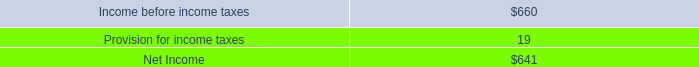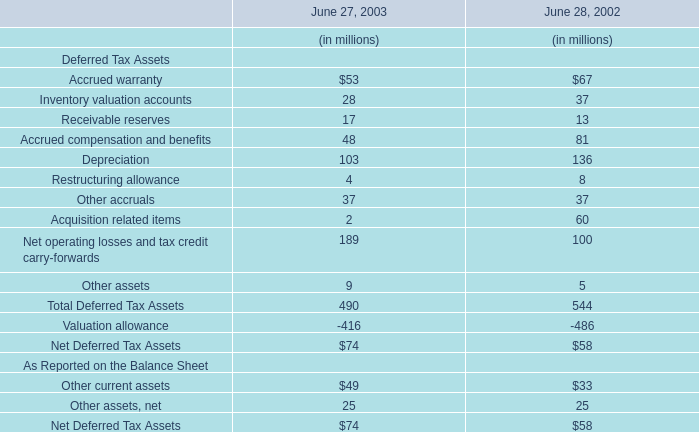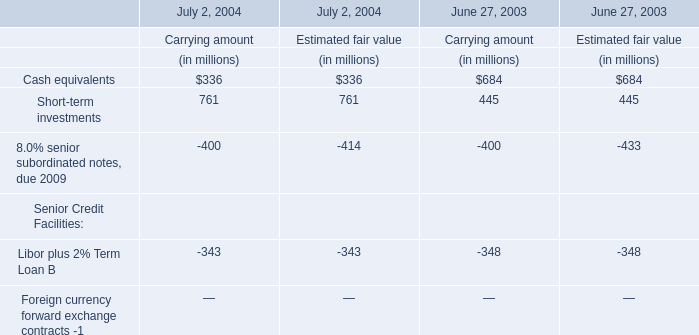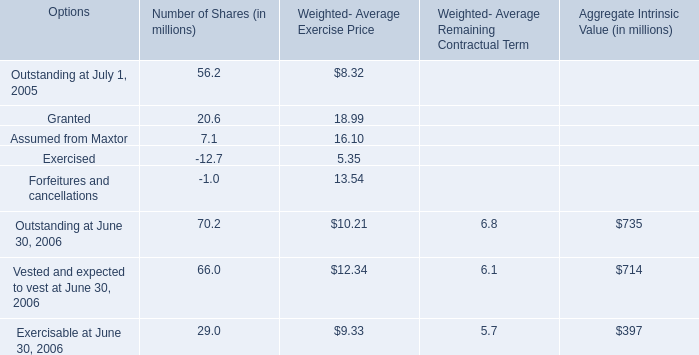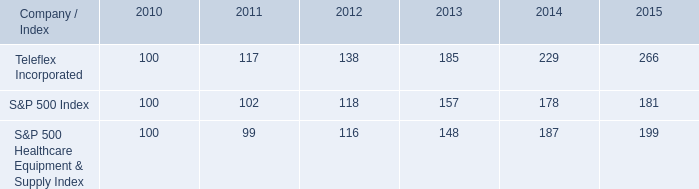What's the sum of all Number of Shares that are greater than 0 in 2005? (in million) 
Computations: ((56.2 + 20.6) + 7.1)
Answer: 83.9. 